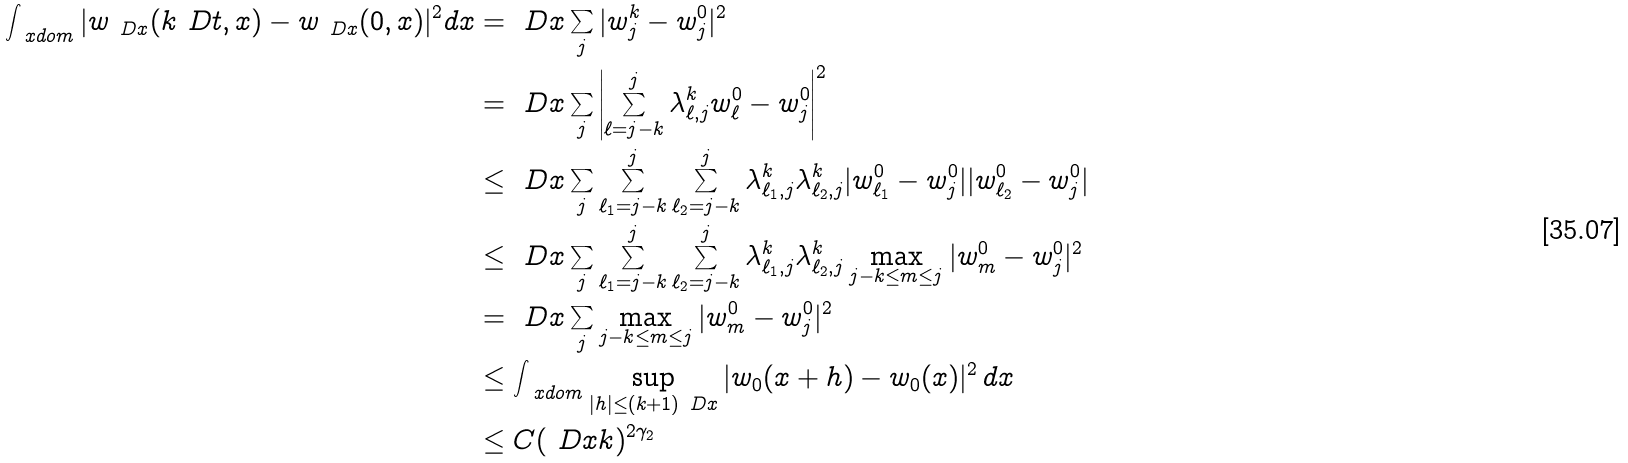<formula> <loc_0><loc_0><loc_500><loc_500>\int _ { \ x d o m } | w _ { \ D x } ( k \ D t , x ) - w _ { \ D x } ( 0 , x ) | ^ { 2 } d x & = \ D x \sum _ { j } | w ^ { k } _ { j } - w ^ { 0 } _ { j } | ^ { 2 } \\ & = \ D x \sum _ { j } \left | \sum _ { \ell = j - k } ^ { j } \lambda ^ { k } _ { \ell , j } w ^ { 0 } _ { \ell } - w ^ { 0 } _ { j } \right | ^ { 2 } \\ & \leq \ D x \sum _ { j } \sum _ { \ell _ { 1 } = j - k } ^ { j } \sum _ { \ell _ { 2 } = j - k } ^ { j } \lambda ^ { k } _ { \ell _ { 1 } , j } \lambda ^ { k } _ { \ell _ { 2 } , j } | w ^ { 0 } _ { \ell _ { 1 } } - w ^ { 0 } _ { j } | | w ^ { 0 } _ { \ell _ { 2 } } - w ^ { 0 } _ { j } | \\ & \leq \ D x \sum _ { j } \sum _ { \ell _ { 1 } = j - k } ^ { j } \sum _ { \ell _ { 2 } = j - k } ^ { j } \lambda ^ { k } _ { \ell _ { 1 } , j } \lambda ^ { k } _ { \ell _ { 2 } , j } \max _ { j - k \leq m \leq j } | w ^ { 0 } _ { m } - w ^ { 0 } _ { j } | ^ { 2 } \\ & = \ D x \sum _ { j } \max _ { j - k \leq m \leq j } | w ^ { 0 } _ { m } - w ^ { 0 } _ { j } | ^ { 2 } \\ & \leq \int _ { \ x d o m } \sup _ { | h | \leq ( k + 1 ) \ D x } | w _ { 0 } ( x + h ) - w _ { 0 } ( x ) | ^ { 2 } \, d x \\ & \leq C ( \ D x k ) ^ { 2 \gamma _ { 2 } }</formula> 